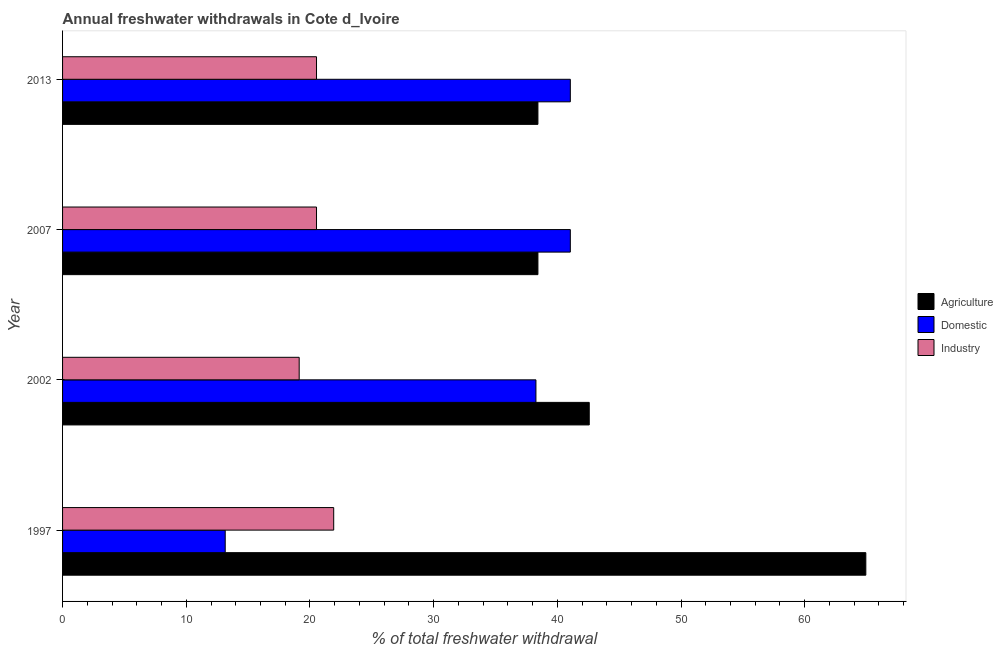How many different coloured bars are there?
Give a very brief answer. 3. How many groups of bars are there?
Your response must be concise. 4. Are the number of bars per tick equal to the number of legend labels?
Provide a succinct answer. Yes. How many bars are there on the 1st tick from the bottom?
Ensure brevity in your answer.  3. What is the label of the 2nd group of bars from the top?
Provide a succinct answer. 2007. In how many cases, is the number of bars for a given year not equal to the number of legend labels?
Make the answer very short. 0. What is the percentage of freshwater withdrawal for domestic purposes in 1997?
Offer a terse response. 13.15. Across all years, what is the maximum percentage of freshwater withdrawal for industry?
Make the answer very short. 21.92. Across all years, what is the minimum percentage of freshwater withdrawal for domestic purposes?
Give a very brief answer. 13.15. In which year was the percentage of freshwater withdrawal for domestic purposes maximum?
Keep it short and to the point. 2007. What is the total percentage of freshwater withdrawal for agriculture in the graph?
Your answer should be very brief. 184.38. What is the difference between the percentage of freshwater withdrawal for industry in 2007 and the percentage of freshwater withdrawal for agriculture in 2002?
Ensure brevity in your answer.  -22.05. What is the average percentage of freshwater withdrawal for industry per year?
Make the answer very short. 20.53. In the year 2002, what is the difference between the percentage of freshwater withdrawal for domestic purposes and percentage of freshwater withdrawal for industry?
Offer a terse response. 19.14. In how many years, is the percentage of freshwater withdrawal for domestic purposes greater than 18 %?
Offer a terse response. 3. What is the ratio of the percentage of freshwater withdrawal for agriculture in 2002 to that in 2007?
Ensure brevity in your answer.  1.11. Is the percentage of freshwater withdrawal for industry in 1997 less than that in 2013?
Offer a very short reply. No. Is the difference between the percentage of freshwater withdrawal for agriculture in 2002 and 2013 greater than the difference between the percentage of freshwater withdrawal for industry in 2002 and 2013?
Provide a short and direct response. Yes. What is the difference between the highest and the second highest percentage of freshwater withdrawal for domestic purposes?
Offer a terse response. 0. What is the difference between the highest and the lowest percentage of freshwater withdrawal for industry?
Make the answer very short. 2.79. In how many years, is the percentage of freshwater withdrawal for domestic purposes greater than the average percentage of freshwater withdrawal for domestic purposes taken over all years?
Provide a succinct answer. 3. Is the sum of the percentage of freshwater withdrawal for domestic purposes in 2007 and 2013 greater than the maximum percentage of freshwater withdrawal for industry across all years?
Provide a short and direct response. Yes. What does the 1st bar from the top in 2007 represents?
Offer a terse response. Industry. What does the 3rd bar from the bottom in 2007 represents?
Your answer should be compact. Industry. Is it the case that in every year, the sum of the percentage of freshwater withdrawal for agriculture and percentage of freshwater withdrawal for domestic purposes is greater than the percentage of freshwater withdrawal for industry?
Your answer should be compact. Yes. How many years are there in the graph?
Ensure brevity in your answer.  4. Does the graph contain grids?
Your response must be concise. No. Where does the legend appear in the graph?
Keep it short and to the point. Center right. How many legend labels are there?
Offer a terse response. 3. How are the legend labels stacked?
Give a very brief answer. Vertical. What is the title of the graph?
Offer a terse response. Annual freshwater withdrawals in Cote d_Ivoire. Does "Unemployment benefits" appear as one of the legend labels in the graph?
Provide a succinct answer. No. What is the label or title of the X-axis?
Offer a terse response. % of total freshwater withdrawal. What is the label or title of the Y-axis?
Give a very brief answer. Year. What is the % of total freshwater withdrawal of Agriculture in 1997?
Your answer should be compact. 64.94. What is the % of total freshwater withdrawal of Domestic in 1997?
Your answer should be compact. 13.15. What is the % of total freshwater withdrawal of Industry in 1997?
Ensure brevity in your answer.  21.92. What is the % of total freshwater withdrawal in Agriculture in 2002?
Your response must be concise. 42.58. What is the % of total freshwater withdrawal of Domestic in 2002?
Provide a short and direct response. 38.27. What is the % of total freshwater withdrawal in Industry in 2002?
Provide a succinct answer. 19.13. What is the % of total freshwater withdrawal of Agriculture in 2007?
Provide a succinct answer. 38.43. What is the % of total freshwater withdrawal of Domestic in 2007?
Give a very brief answer. 41.05. What is the % of total freshwater withdrawal of Industry in 2007?
Give a very brief answer. 20.53. What is the % of total freshwater withdrawal of Agriculture in 2013?
Your answer should be very brief. 38.43. What is the % of total freshwater withdrawal in Domestic in 2013?
Give a very brief answer. 41.05. What is the % of total freshwater withdrawal in Industry in 2013?
Provide a short and direct response. 20.53. Across all years, what is the maximum % of total freshwater withdrawal of Agriculture?
Your answer should be very brief. 64.94. Across all years, what is the maximum % of total freshwater withdrawal in Domestic?
Your answer should be very brief. 41.05. Across all years, what is the maximum % of total freshwater withdrawal in Industry?
Your response must be concise. 21.92. Across all years, what is the minimum % of total freshwater withdrawal in Agriculture?
Keep it short and to the point. 38.43. Across all years, what is the minimum % of total freshwater withdrawal in Domestic?
Your answer should be compact. 13.15. Across all years, what is the minimum % of total freshwater withdrawal in Industry?
Ensure brevity in your answer.  19.13. What is the total % of total freshwater withdrawal of Agriculture in the graph?
Keep it short and to the point. 184.38. What is the total % of total freshwater withdrawal of Domestic in the graph?
Provide a short and direct response. 133.52. What is the total % of total freshwater withdrawal in Industry in the graph?
Ensure brevity in your answer.  82.11. What is the difference between the % of total freshwater withdrawal in Agriculture in 1997 and that in 2002?
Offer a very short reply. 22.36. What is the difference between the % of total freshwater withdrawal in Domestic in 1997 and that in 2002?
Ensure brevity in your answer.  -25.12. What is the difference between the % of total freshwater withdrawal in Industry in 1997 and that in 2002?
Provide a short and direct response. 2.79. What is the difference between the % of total freshwater withdrawal of Agriculture in 1997 and that in 2007?
Offer a very short reply. 26.51. What is the difference between the % of total freshwater withdrawal in Domestic in 1997 and that in 2007?
Give a very brief answer. -27.9. What is the difference between the % of total freshwater withdrawal of Industry in 1997 and that in 2007?
Ensure brevity in your answer.  1.39. What is the difference between the % of total freshwater withdrawal of Agriculture in 1997 and that in 2013?
Offer a terse response. 26.51. What is the difference between the % of total freshwater withdrawal of Domestic in 1997 and that in 2013?
Offer a terse response. -27.9. What is the difference between the % of total freshwater withdrawal in Industry in 1997 and that in 2013?
Your answer should be compact. 1.39. What is the difference between the % of total freshwater withdrawal of Agriculture in 2002 and that in 2007?
Make the answer very short. 4.15. What is the difference between the % of total freshwater withdrawal in Domestic in 2002 and that in 2007?
Your response must be concise. -2.78. What is the difference between the % of total freshwater withdrawal of Agriculture in 2002 and that in 2013?
Provide a short and direct response. 4.15. What is the difference between the % of total freshwater withdrawal of Domestic in 2002 and that in 2013?
Offer a very short reply. -2.78. What is the difference between the % of total freshwater withdrawal of Industry in 2002 and that in 2013?
Offer a very short reply. -1.4. What is the difference between the % of total freshwater withdrawal in Domestic in 2007 and that in 2013?
Give a very brief answer. 0. What is the difference between the % of total freshwater withdrawal in Industry in 2007 and that in 2013?
Give a very brief answer. 0. What is the difference between the % of total freshwater withdrawal in Agriculture in 1997 and the % of total freshwater withdrawal in Domestic in 2002?
Keep it short and to the point. 26.67. What is the difference between the % of total freshwater withdrawal in Agriculture in 1997 and the % of total freshwater withdrawal in Industry in 2002?
Keep it short and to the point. 45.81. What is the difference between the % of total freshwater withdrawal of Domestic in 1997 and the % of total freshwater withdrawal of Industry in 2002?
Give a very brief answer. -5.98. What is the difference between the % of total freshwater withdrawal of Agriculture in 1997 and the % of total freshwater withdrawal of Domestic in 2007?
Keep it short and to the point. 23.89. What is the difference between the % of total freshwater withdrawal in Agriculture in 1997 and the % of total freshwater withdrawal in Industry in 2007?
Provide a short and direct response. 44.41. What is the difference between the % of total freshwater withdrawal in Domestic in 1997 and the % of total freshwater withdrawal in Industry in 2007?
Your response must be concise. -7.38. What is the difference between the % of total freshwater withdrawal of Agriculture in 1997 and the % of total freshwater withdrawal of Domestic in 2013?
Offer a very short reply. 23.89. What is the difference between the % of total freshwater withdrawal in Agriculture in 1997 and the % of total freshwater withdrawal in Industry in 2013?
Provide a short and direct response. 44.41. What is the difference between the % of total freshwater withdrawal in Domestic in 1997 and the % of total freshwater withdrawal in Industry in 2013?
Ensure brevity in your answer.  -7.38. What is the difference between the % of total freshwater withdrawal of Agriculture in 2002 and the % of total freshwater withdrawal of Domestic in 2007?
Make the answer very short. 1.53. What is the difference between the % of total freshwater withdrawal of Agriculture in 2002 and the % of total freshwater withdrawal of Industry in 2007?
Offer a very short reply. 22.05. What is the difference between the % of total freshwater withdrawal of Domestic in 2002 and the % of total freshwater withdrawal of Industry in 2007?
Your response must be concise. 17.74. What is the difference between the % of total freshwater withdrawal of Agriculture in 2002 and the % of total freshwater withdrawal of Domestic in 2013?
Offer a very short reply. 1.53. What is the difference between the % of total freshwater withdrawal in Agriculture in 2002 and the % of total freshwater withdrawal in Industry in 2013?
Ensure brevity in your answer.  22.05. What is the difference between the % of total freshwater withdrawal in Domestic in 2002 and the % of total freshwater withdrawal in Industry in 2013?
Provide a succinct answer. 17.74. What is the difference between the % of total freshwater withdrawal in Agriculture in 2007 and the % of total freshwater withdrawal in Domestic in 2013?
Offer a terse response. -2.62. What is the difference between the % of total freshwater withdrawal in Domestic in 2007 and the % of total freshwater withdrawal in Industry in 2013?
Your answer should be compact. 20.52. What is the average % of total freshwater withdrawal in Agriculture per year?
Give a very brief answer. 46.09. What is the average % of total freshwater withdrawal in Domestic per year?
Provide a succinct answer. 33.38. What is the average % of total freshwater withdrawal in Industry per year?
Make the answer very short. 20.53. In the year 1997, what is the difference between the % of total freshwater withdrawal in Agriculture and % of total freshwater withdrawal in Domestic?
Provide a succinct answer. 51.79. In the year 1997, what is the difference between the % of total freshwater withdrawal of Agriculture and % of total freshwater withdrawal of Industry?
Your answer should be compact. 43.02. In the year 1997, what is the difference between the % of total freshwater withdrawal of Domestic and % of total freshwater withdrawal of Industry?
Your answer should be very brief. -8.77. In the year 2002, what is the difference between the % of total freshwater withdrawal of Agriculture and % of total freshwater withdrawal of Domestic?
Your answer should be compact. 4.31. In the year 2002, what is the difference between the % of total freshwater withdrawal in Agriculture and % of total freshwater withdrawal in Industry?
Ensure brevity in your answer.  23.45. In the year 2002, what is the difference between the % of total freshwater withdrawal in Domestic and % of total freshwater withdrawal in Industry?
Make the answer very short. 19.14. In the year 2007, what is the difference between the % of total freshwater withdrawal in Agriculture and % of total freshwater withdrawal in Domestic?
Give a very brief answer. -2.62. In the year 2007, what is the difference between the % of total freshwater withdrawal in Domestic and % of total freshwater withdrawal in Industry?
Keep it short and to the point. 20.52. In the year 2013, what is the difference between the % of total freshwater withdrawal in Agriculture and % of total freshwater withdrawal in Domestic?
Ensure brevity in your answer.  -2.62. In the year 2013, what is the difference between the % of total freshwater withdrawal in Agriculture and % of total freshwater withdrawal in Industry?
Offer a terse response. 17.9. In the year 2013, what is the difference between the % of total freshwater withdrawal in Domestic and % of total freshwater withdrawal in Industry?
Keep it short and to the point. 20.52. What is the ratio of the % of total freshwater withdrawal in Agriculture in 1997 to that in 2002?
Keep it short and to the point. 1.53. What is the ratio of the % of total freshwater withdrawal in Domestic in 1997 to that in 2002?
Your answer should be very brief. 0.34. What is the ratio of the % of total freshwater withdrawal of Industry in 1997 to that in 2002?
Keep it short and to the point. 1.15. What is the ratio of the % of total freshwater withdrawal in Agriculture in 1997 to that in 2007?
Give a very brief answer. 1.69. What is the ratio of the % of total freshwater withdrawal of Domestic in 1997 to that in 2007?
Your answer should be compact. 0.32. What is the ratio of the % of total freshwater withdrawal of Industry in 1997 to that in 2007?
Give a very brief answer. 1.07. What is the ratio of the % of total freshwater withdrawal of Agriculture in 1997 to that in 2013?
Offer a terse response. 1.69. What is the ratio of the % of total freshwater withdrawal in Domestic in 1997 to that in 2013?
Provide a short and direct response. 0.32. What is the ratio of the % of total freshwater withdrawal in Industry in 1997 to that in 2013?
Your answer should be compact. 1.07. What is the ratio of the % of total freshwater withdrawal of Agriculture in 2002 to that in 2007?
Your answer should be very brief. 1.11. What is the ratio of the % of total freshwater withdrawal in Domestic in 2002 to that in 2007?
Your response must be concise. 0.93. What is the ratio of the % of total freshwater withdrawal of Industry in 2002 to that in 2007?
Keep it short and to the point. 0.93. What is the ratio of the % of total freshwater withdrawal of Agriculture in 2002 to that in 2013?
Provide a succinct answer. 1.11. What is the ratio of the % of total freshwater withdrawal in Domestic in 2002 to that in 2013?
Give a very brief answer. 0.93. What is the ratio of the % of total freshwater withdrawal of Industry in 2002 to that in 2013?
Make the answer very short. 0.93. What is the difference between the highest and the second highest % of total freshwater withdrawal of Agriculture?
Your answer should be very brief. 22.36. What is the difference between the highest and the second highest % of total freshwater withdrawal of Industry?
Make the answer very short. 1.39. What is the difference between the highest and the lowest % of total freshwater withdrawal of Agriculture?
Make the answer very short. 26.51. What is the difference between the highest and the lowest % of total freshwater withdrawal of Domestic?
Your answer should be compact. 27.9. What is the difference between the highest and the lowest % of total freshwater withdrawal of Industry?
Offer a terse response. 2.79. 